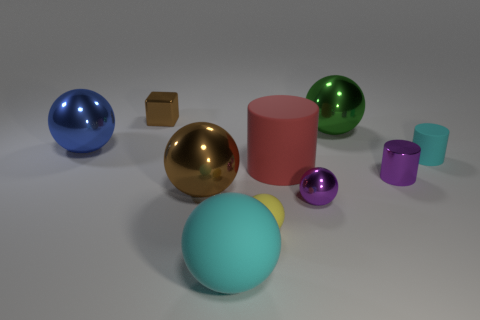Subtract all brown balls. How many balls are left? 5 Subtract all small yellow balls. How many balls are left? 5 Subtract all yellow balls. Subtract all red cylinders. How many balls are left? 5 Subtract all cubes. How many objects are left? 9 Add 1 large red metallic cylinders. How many large red metallic cylinders exist? 1 Subtract 0 red cubes. How many objects are left? 10 Subtract all blue metallic balls. Subtract all red matte cylinders. How many objects are left? 8 Add 8 large green balls. How many large green balls are left? 9 